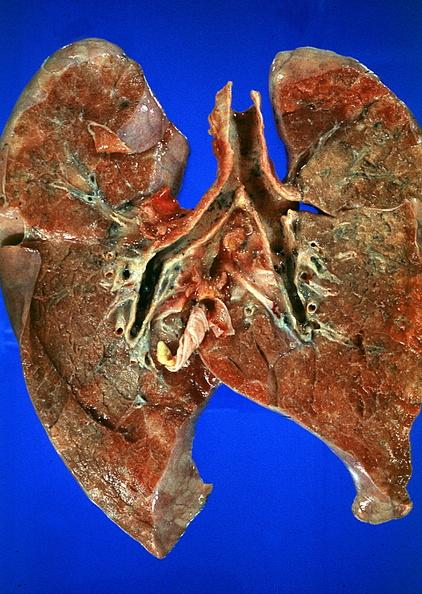does this image show lung?
Answer the question using a single word or phrase. Yes 